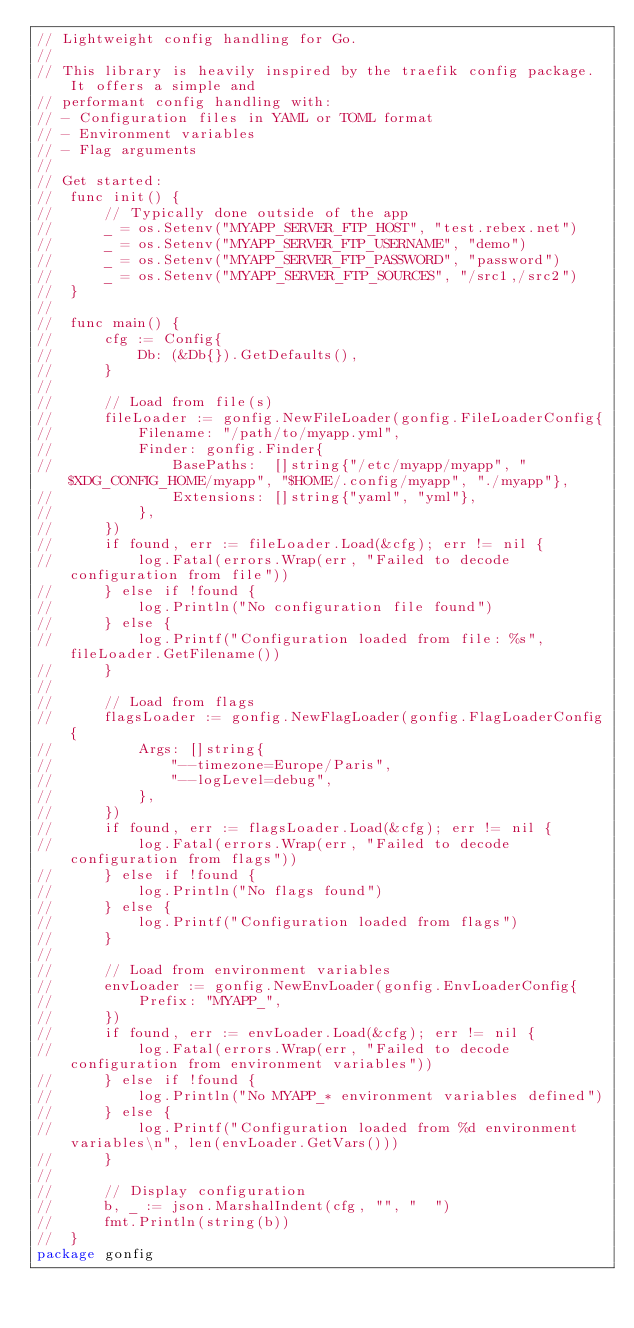Convert code to text. <code><loc_0><loc_0><loc_500><loc_500><_Go_>// Lightweight config handling for Go.
//
// This library is heavily inspired by the traefik config package. It offers a simple and
// performant config handling with:
// - Configuration files in YAML or TOML format
// - Environment variables
// - Flag arguments
//
// Get started:
//  func init() {
//  	// Typically done outside of the app
//  	_ = os.Setenv("MYAPP_SERVER_FTP_HOST", "test.rebex.net")
//  	_ = os.Setenv("MYAPP_SERVER_FTP_USERNAME", "demo")
//  	_ = os.Setenv("MYAPP_SERVER_FTP_PASSWORD", "password")
//  	_ = os.Setenv("MYAPP_SERVER_FTP_SOURCES", "/src1,/src2")
//  }
//
//  func main() {
//  	cfg := Config{
//  		Db: (&Db{}).GetDefaults(),
//  	}
//
//  	// Load from file(s)
//  	fileLoader := gonfig.NewFileLoader(gonfig.FileLoaderConfig{
//  		Filename: "/path/to/myapp.yml",
//  		Finder: gonfig.Finder{
//  			BasePaths:  []string{"/etc/myapp/myapp", "$XDG_CONFIG_HOME/myapp", "$HOME/.config/myapp", "./myapp"},
//  			Extensions: []string{"yaml", "yml"},
//  		},
//  	})
//  	if found, err := fileLoader.Load(&cfg); err != nil {
//  		log.Fatal(errors.Wrap(err, "Failed to decode configuration from file"))
//  	} else if !found {
//  		log.Println("No configuration file found")
//  	} else {
//  		log.Printf("Configuration loaded from file: %s", fileLoader.GetFilename())
//  	}
//
//  	// Load from flags
//  	flagsLoader := gonfig.NewFlagLoader(gonfig.FlagLoaderConfig{
//  		Args: []string{
//  			"--timezone=Europe/Paris",
//  			"--logLevel=debug",
//  		},
//  	})
//  	if found, err := flagsLoader.Load(&cfg); err != nil {
//  		log.Fatal(errors.Wrap(err, "Failed to decode configuration from flags"))
//  	} else if !found {
//  		log.Println("No flags found")
//  	} else {
//  		log.Printf("Configuration loaded from flags")
//  	}
//
//  	// Load from environment variables
//  	envLoader := gonfig.NewEnvLoader(gonfig.EnvLoaderConfig{
//  		Prefix: "MYAPP_",
//  	})
//  	if found, err := envLoader.Load(&cfg); err != nil {
//  		log.Fatal(errors.Wrap(err, "Failed to decode configuration from environment variables"))
//  	} else if !found {
//  		log.Println("No MYAPP_* environment variables defined")
//  	} else {
//  		log.Printf("Configuration loaded from %d environment variables\n", len(envLoader.GetVars()))
//  	}
//
//  	// Display configuration
//  	b, _ := json.MarshalIndent(cfg, "", "  ")
//  	fmt.Println(string(b))
//  }
package gonfig
</code> 